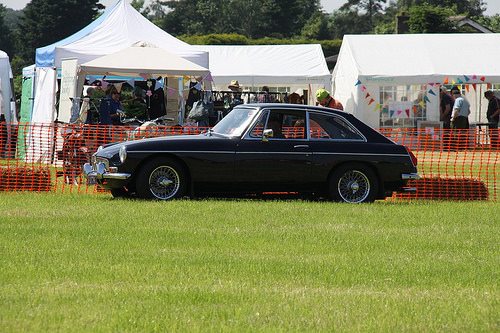<image>
Is there a car on the lawn? Yes. Looking at the image, I can see the car is positioned on top of the lawn, with the lawn providing support. 